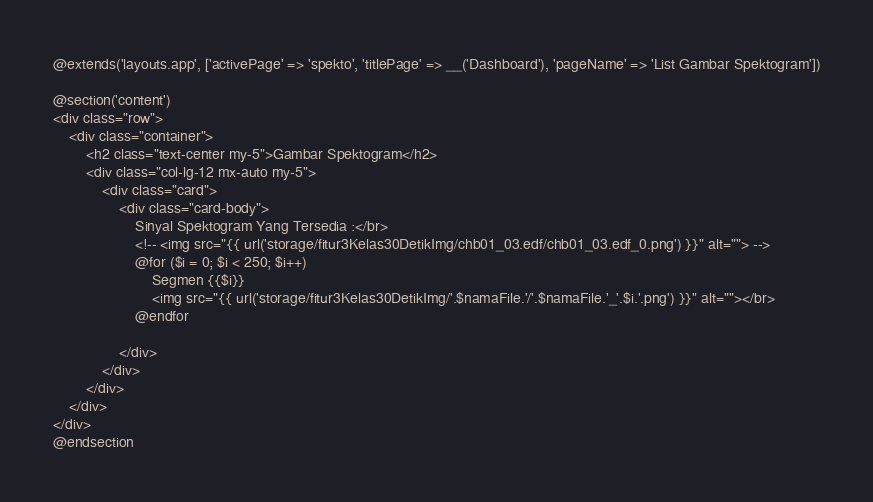<code> <loc_0><loc_0><loc_500><loc_500><_PHP_>@extends('layouts.app', ['activePage' => 'spekto', 'titlePage' => __('Dashboard'), 'pageName' => 'List Gambar Spektogram'])

@section('content')
<div class="row">
    <div class="container">
        <h2 class="text-center my-5">Gambar Spektogram</h2>
        <div class="col-lg-12 mx-auto my-5">
            <div class="card">
                <div class="card-body">
                    Sinyal Spektogram Yang Tersedia :</br>
                    <!-- <img src="{{ url('storage/fitur3Kelas30DetikImg/chb01_03.edf/chb01_03.edf_0.png') }}" alt=""> -->
                    @for ($i = 0; $i < 250; $i++)
                        Segmen {{$i}}
                        <img src="{{ url('storage/fitur3Kelas30DetikImg/'.$namaFile.'/'.$namaFile.'_'.$i.'.png') }}" alt=""></br>
                    @endfor
                
                </div>
            </div>
        </div>
    </div>
</div>
@endsection</code> 